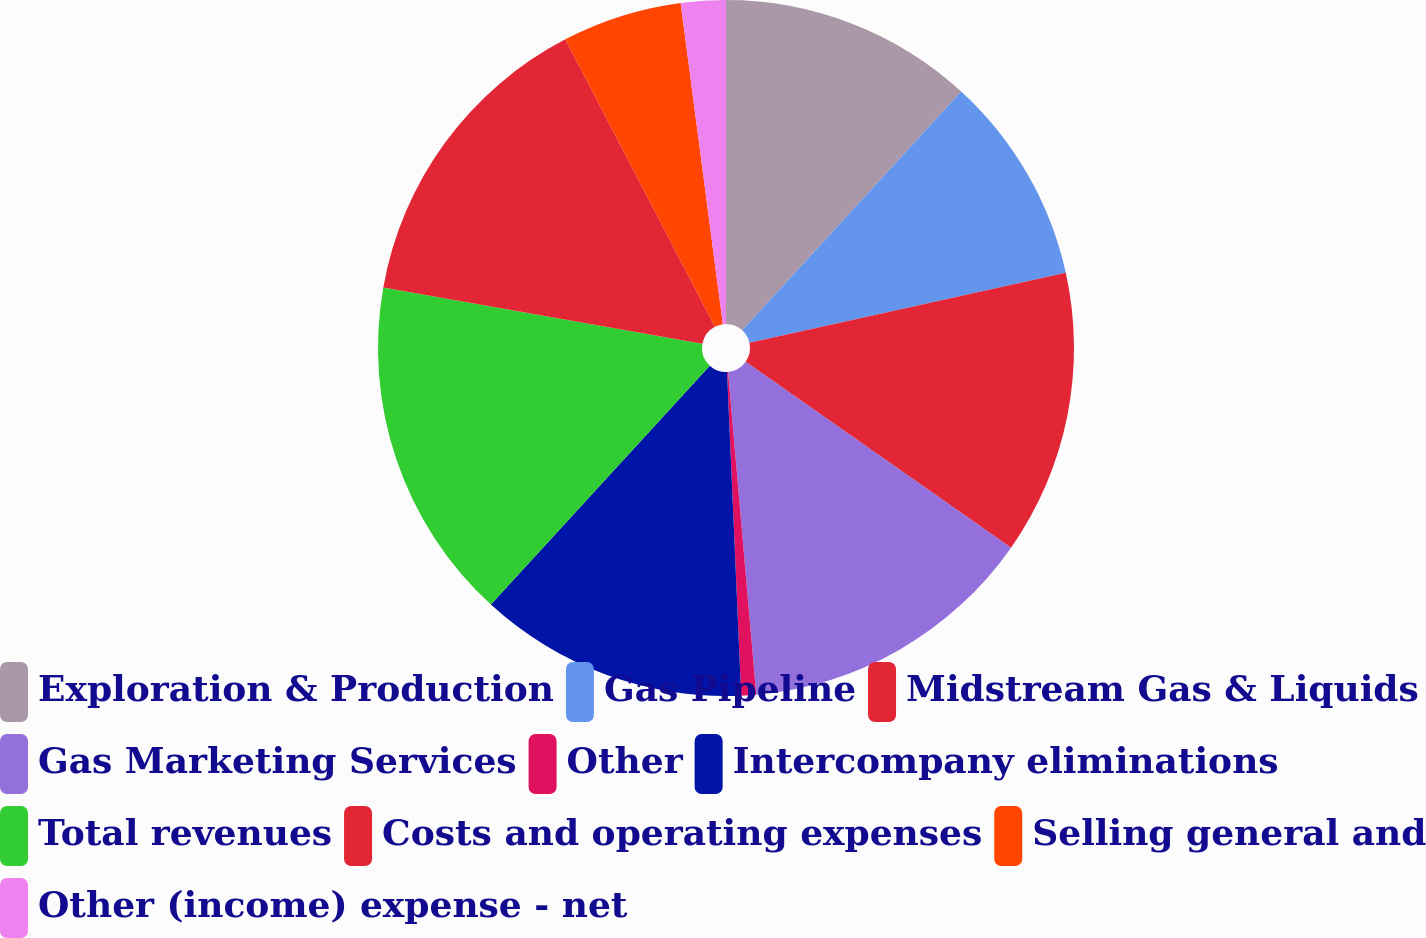Convert chart to OTSL. <chart><loc_0><loc_0><loc_500><loc_500><pie_chart><fcel>Exploration & Production<fcel>Gas Pipeline<fcel>Midstream Gas & Liquids<fcel>Gas Marketing Services<fcel>Other<fcel>Intercompany eliminations<fcel>Total revenues<fcel>Costs and operating expenses<fcel>Selling general and<fcel>Other (income) expense - net<nl><fcel>11.81%<fcel>9.72%<fcel>13.19%<fcel>13.89%<fcel>0.69%<fcel>12.5%<fcel>15.97%<fcel>14.58%<fcel>5.56%<fcel>2.08%<nl></chart> 